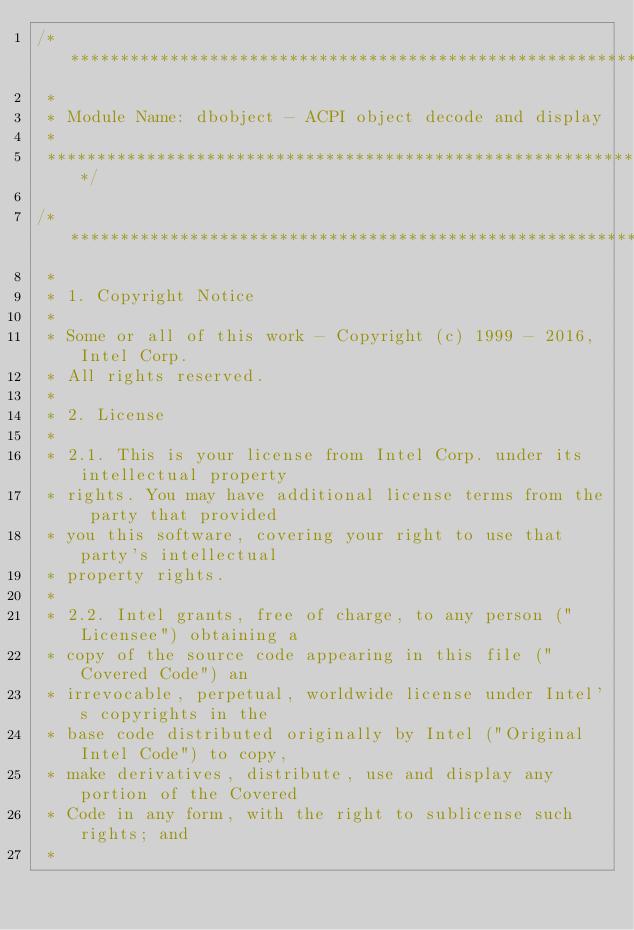Convert code to text. <code><loc_0><loc_0><loc_500><loc_500><_C_>/*******************************************************************************
 *
 * Module Name: dbobject - ACPI object decode and display
 *
 ******************************************************************************/

/******************************************************************************
 *
 * 1. Copyright Notice
 *
 * Some or all of this work - Copyright (c) 1999 - 2016, Intel Corp.
 * All rights reserved.
 *
 * 2. License
 *
 * 2.1. This is your license from Intel Corp. under its intellectual property
 * rights. You may have additional license terms from the party that provided
 * you this software, covering your right to use that party's intellectual
 * property rights.
 *
 * 2.2. Intel grants, free of charge, to any person ("Licensee") obtaining a
 * copy of the source code appearing in this file ("Covered Code") an
 * irrevocable, perpetual, worldwide license under Intel's copyrights in the
 * base code distributed originally by Intel ("Original Intel Code") to copy,
 * make derivatives, distribute, use and display any portion of the Covered
 * Code in any form, with the right to sublicense such rights; and
 *</code> 